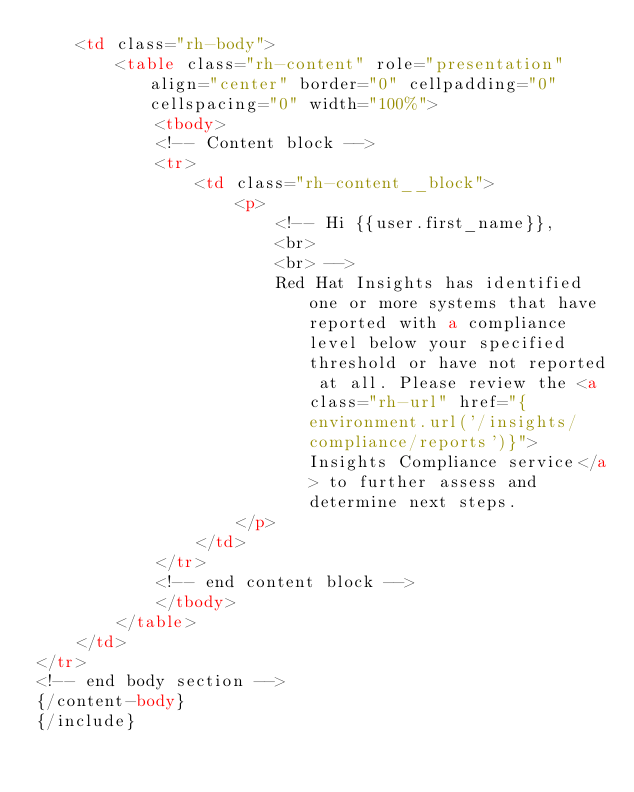Convert code to text. <code><loc_0><loc_0><loc_500><loc_500><_HTML_>    <td class="rh-body">
        <table class="rh-content" role="presentation" align="center" border="0" cellpadding="0" cellspacing="0" width="100%">
            <tbody>
            <!-- Content block -->
            <tr>
                <td class="rh-content__block">
                    <p>
                        <!-- Hi {{user.first_name}},
                        <br>
                        <br> -->
                        Red Hat Insights has identified one or more systems that have reported with a compliance level below your specified threshold or have not reported at all. Please review the <a class="rh-url" href="{environment.url('/insights/compliance/reports')}">Insights Compliance service</a> to further assess and determine next steps.
                    </p>
                </td>
            </tr>
            <!-- end content block -->
            </tbody>
        </table>
    </td>
</tr>
<!-- end body section -->
{/content-body}
{/include}
</code> 